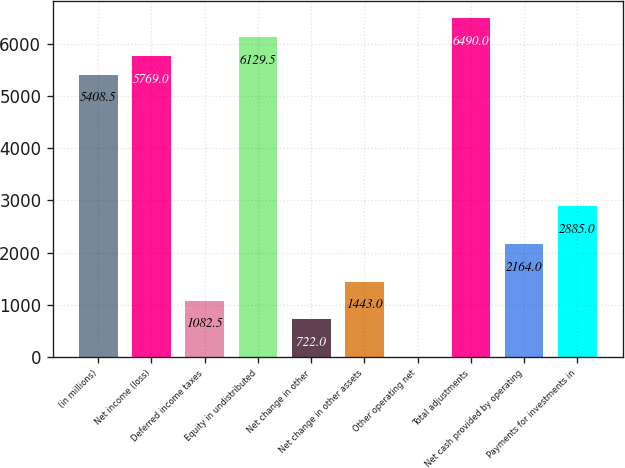Convert chart. <chart><loc_0><loc_0><loc_500><loc_500><bar_chart><fcel>(in millions)<fcel>Net income (loss)<fcel>Deferred income taxes<fcel>Equity in undistributed<fcel>Net change in other<fcel>Net change in other assets<fcel>Other operating net<fcel>Total adjustments<fcel>Net cash provided by operating<fcel>Payments for investments in<nl><fcel>5408.5<fcel>5769<fcel>1082.5<fcel>6129.5<fcel>722<fcel>1443<fcel>1<fcel>6490<fcel>2164<fcel>2885<nl></chart> 